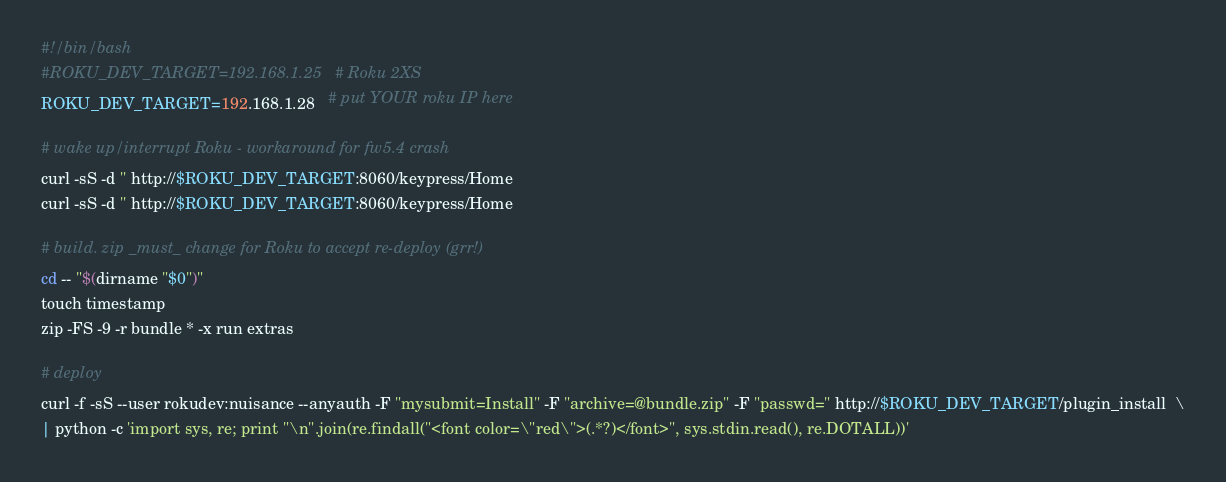Convert code to text. <code><loc_0><loc_0><loc_500><loc_500><_Bash_>#!/bin/bash
#ROKU_DEV_TARGET=192.168.1.25   # Roku 2XS
ROKU_DEV_TARGET=192.168.1.28   # put YOUR roku IP here

# wake up/interrupt Roku - workaround for fw5.4 crash
curl -sS -d '' http://$ROKU_DEV_TARGET:8060/keypress/Home
curl -sS -d '' http://$ROKU_DEV_TARGET:8060/keypress/Home

# build. zip _must_ change for Roku to accept re-deploy (grr!)
cd -- "$(dirname "$0")"
touch timestamp
zip -FS -9 -r bundle * -x run extras

# deploy
curl -f -sS --user rokudev:nuisance --anyauth -F "mysubmit=Install" -F "archive=@bundle.zip" -F "passwd=" http://$ROKU_DEV_TARGET/plugin_install  \
| python -c 'import sys, re; print "\n".join(re.findall("<font color=\"red\">(.*?)</font>", sys.stdin.read(), re.DOTALL))'</code> 